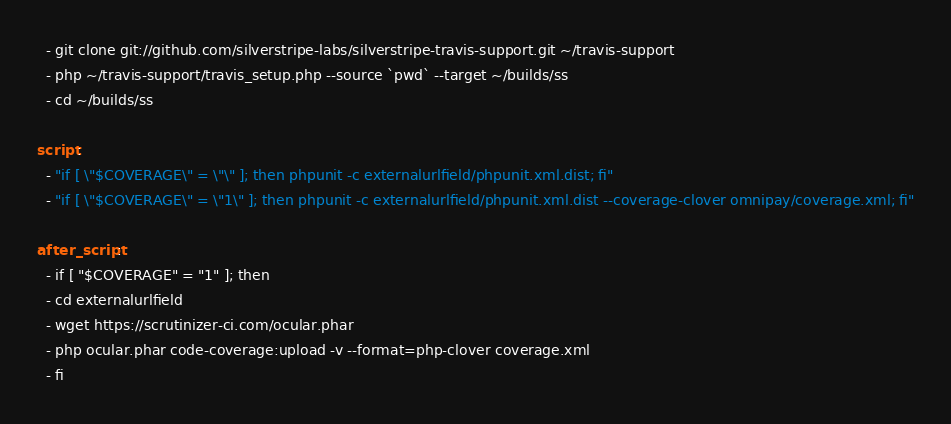Convert code to text. <code><loc_0><loc_0><loc_500><loc_500><_YAML_>  - git clone git://github.com/silverstripe-labs/silverstripe-travis-support.git ~/travis-support
  - php ~/travis-support/travis_setup.php --source `pwd` --target ~/builds/ss
  - cd ~/builds/ss

script:
  - "if [ \"$COVERAGE\" = \"\" ]; then phpunit -c externalurlfield/phpunit.xml.dist; fi"
  - "if [ \"$COVERAGE\" = \"1\" ]; then phpunit -c externalurlfield/phpunit.xml.dist --coverage-clover omnipay/coverage.xml; fi"

after_script:
  - if [ "$COVERAGE" = "1" ]; then
  - cd externalurlfield
  - wget https://scrutinizer-ci.com/ocular.phar
  - php ocular.phar code-coverage:upload -v --format=php-clover coverage.xml
  - fi
</code> 